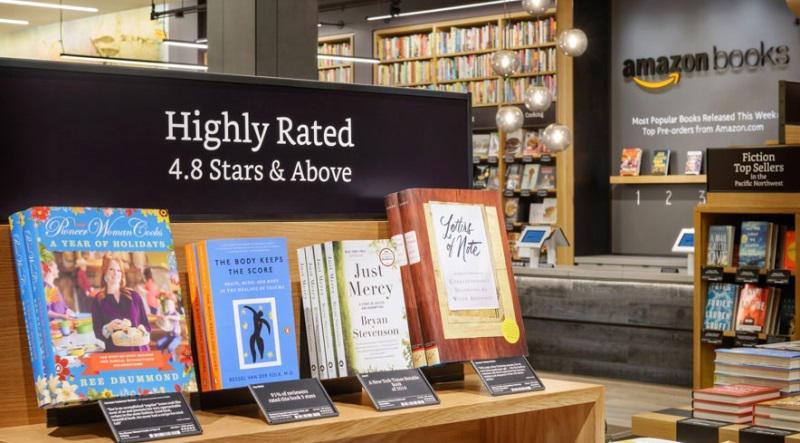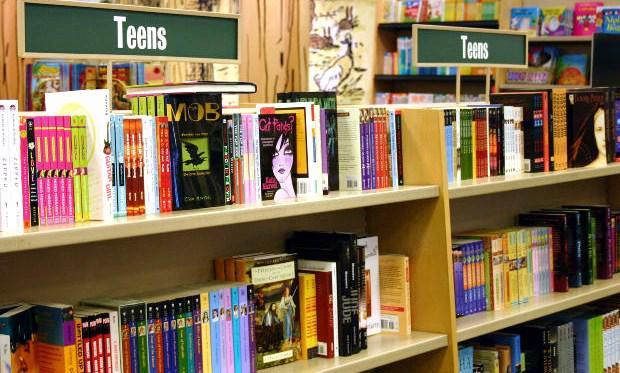The first image is the image on the left, the second image is the image on the right. Examine the images to the left and right. Is the description "In one of the images there are at least three people shopping in a bookstore." accurate? Answer yes or no. No. The first image is the image on the left, the second image is the image on the right. For the images displayed, is the sentence "Left image includes multiple media items with anime characters on the cover and a display featuring bright red and blonde wood." factually correct? Answer yes or no. No. 